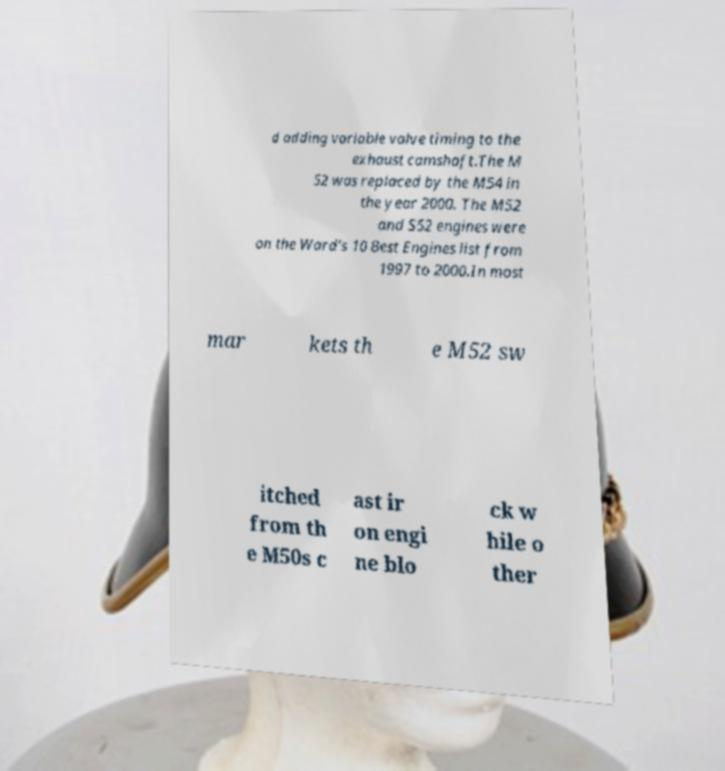I need the written content from this picture converted into text. Can you do that? d adding variable valve timing to the exhaust camshaft.The M 52 was replaced by the M54 in the year 2000. The M52 and S52 engines were on the Ward's 10 Best Engines list from 1997 to 2000.In most mar kets th e M52 sw itched from th e M50s c ast ir on engi ne blo ck w hile o ther 